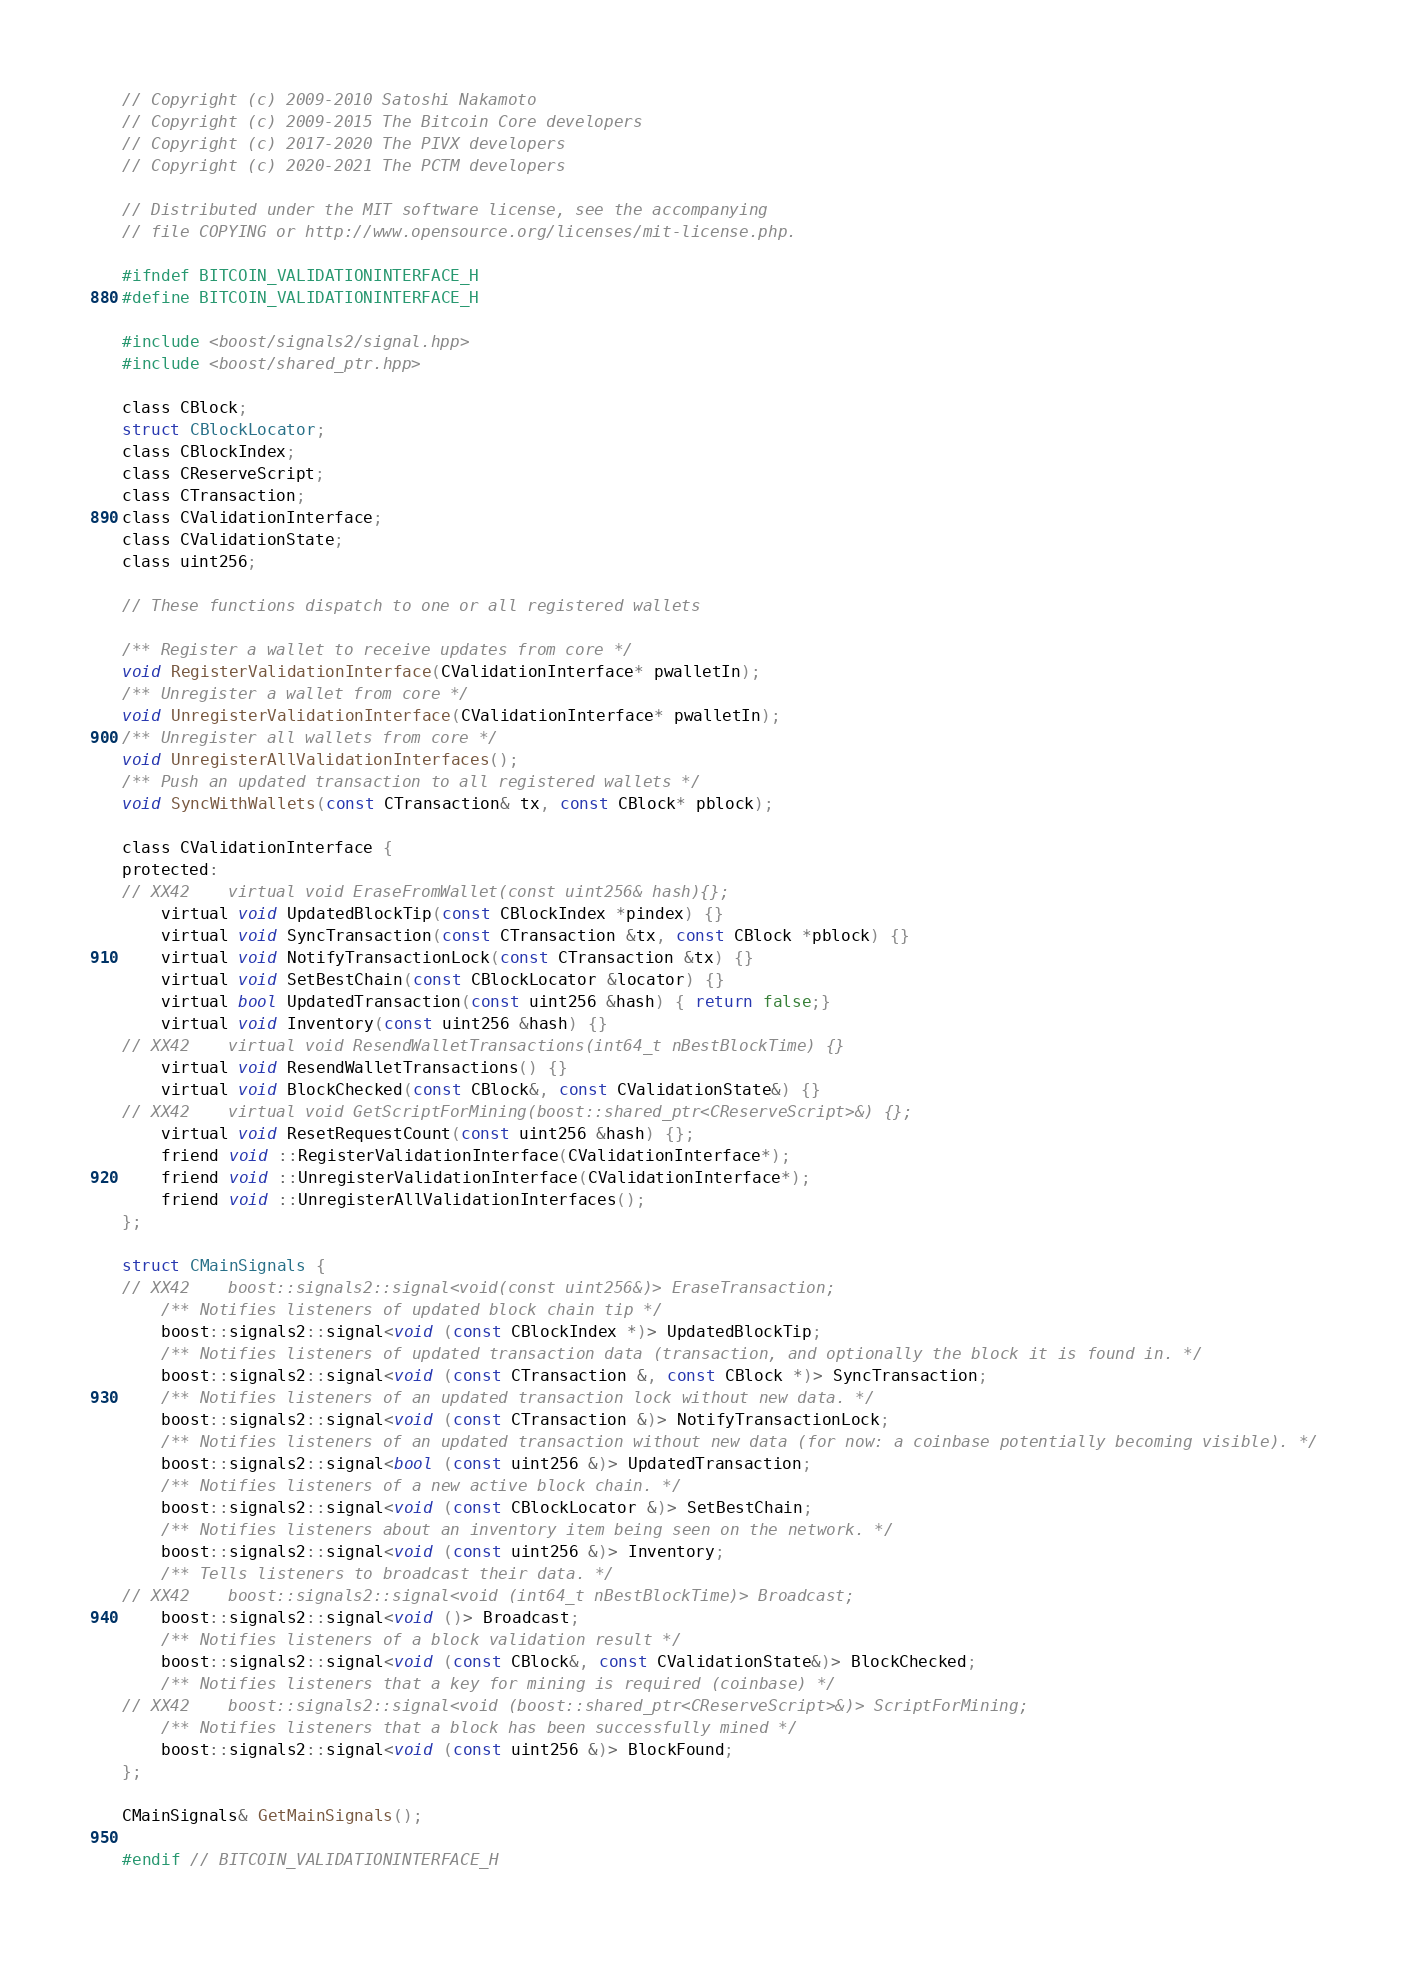Convert code to text. <code><loc_0><loc_0><loc_500><loc_500><_C_>// Copyright (c) 2009-2010 Satoshi Nakamoto
// Copyright (c) 2009-2015 The Bitcoin Core developers
// Copyright (c) 2017-2020 The PIVX developers
// Copyright (c) 2020-2021 The PCTM developers

// Distributed under the MIT software license, see the accompanying
// file COPYING or http://www.opensource.org/licenses/mit-license.php.

#ifndef BITCOIN_VALIDATIONINTERFACE_H
#define BITCOIN_VALIDATIONINTERFACE_H

#include <boost/signals2/signal.hpp>
#include <boost/shared_ptr.hpp>

class CBlock;
struct CBlockLocator;
class CBlockIndex;
class CReserveScript;
class CTransaction;
class CValidationInterface;
class CValidationState;
class uint256;

// These functions dispatch to one or all registered wallets

/** Register a wallet to receive updates from core */
void RegisterValidationInterface(CValidationInterface* pwalletIn);
/** Unregister a wallet from core */
void UnregisterValidationInterface(CValidationInterface* pwalletIn);
/** Unregister all wallets from core */
void UnregisterAllValidationInterfaces();
/** Push an updated transaction to all registered wallets */
void SyncWithWallets(const CTransaction& tx, const CBlock* pblock);

class CValidationInterface {
protected:
// XX42    virtual void EraseFromWallet(const uint256& hash){};
    virtual void UpdatedBlockTip(const CBlockIndex *pindex) {}
    virtual void SyncTransaction(const CTransaction &tx, const CBlock *pblock) {}
    virtual void NotifyTransactionLock(const CTransaction &tx) {}
    virtual void SetBestChain(const CBlockLocator &locator) {}
    virtual bool UpdatedTransaction(const uint256 &hash) { return false;}
    virtual void Inventory(const uint256 &hash) {}
// XX42    virtual void ResendWalletTransactions(int64_t nBestBlockTime) {}
    virtual void ResendWalletTransactions() {}
    virtual void BlockChecked(const CBlock&, const CValidationState&) {}
// XX42    virtual void GetScriptForMining(boost::shared_ptr<CReserveScript>&) {};
    virtual void ResetRequestCount(const uint256 &hash) {};
    friend void ::RegisterValidationInterface(CValidationInterface*);
    friend void ::UnregisterValidationInterface(CValidationInterface*);
    friend void ::UnregisterAllValidationInterfaces();
};

struct CMainSignals {
// XX42    boost::signals2::signal<void(const uint256&)> EraseTransaction;
    /** Notifies listeners of updated block chain tip */
    boost::signals2::signal<void (const CBlockIndex *)> UpdatedBlockTip;
    /** Notifies listeners of updated transaction data (transaction, and optionally the block it is found in. */
    boost::signals2::signal<void (const CTransaction &, const CBlock *)> SyncTransaction;
    /** Notifies listeners of an updated transaction lock without new data. */
    boost::signals2::signal<void (const CTransaction &)> NotifyTransactionLock;
    /** Notifies listeners of an updated transaction without new data (for now: a coinbase potentially becoming visible). */
    boost::signals2::signal<bool (const uint256 &)> UpdatedTransaction;
    /** Notifies listeners of a new active block chain. */
    boost::signals2::signal<void (const CBlockLocator &)> SetBestChain;
    /** Notifies listeners about an inventory item being seen on the network. */
    boost::signals2::signal<void (const uint256 &)> Inventory;
    /** Tells listeners to broadcast their data. */
// XX42    boost::signals2::signal<void (int64_t nBestBlockTime)> Broadcast;
    boost::signals2::signal<void ()> Broadcast;
    /** Notifies listeners of a block validation result */
    boost::signals2::signal<void (const CBlock&, const CValidationState&)> BlockChecked;
    /** Notifies listeners that a key for mining is required (coinbase) */
// XX42    boost::signals2::signal<void (boost::shared_ptr<CReserveScript>&)> ScriptForMining;
    /** Notifies listeners that a block has been successfully mined */
    boost::signals2::signal<void (const uint256 &)> BlockFound;
};

CMainSignals& GetMainSignals();

#endif // BITCOIN_VALIDATIONINTERFACE_H
</code> 